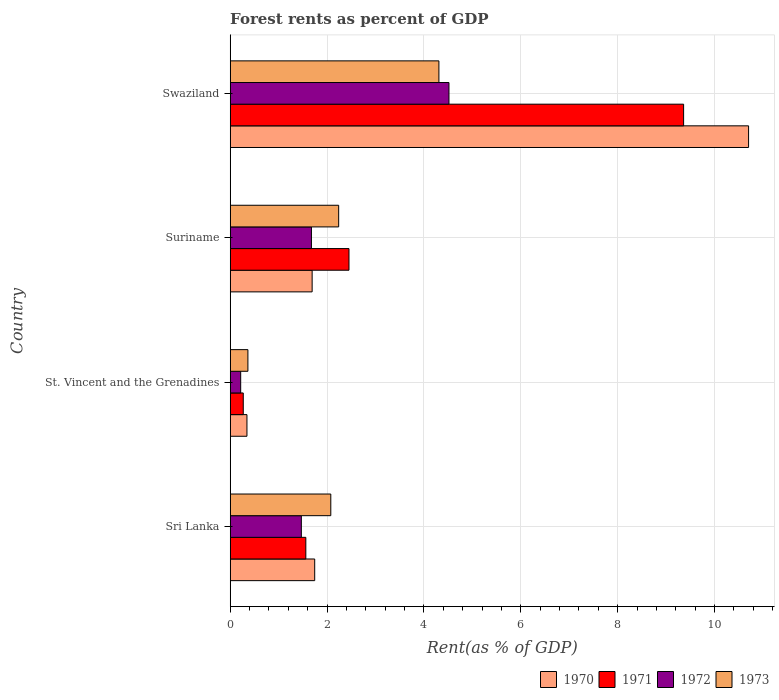How many different coloured bars are there?
Provide a succinct answer. 4. How many groups of bars are there?
Keep it short and to the point. 4. Are the number of bars on each tick of the Y-axis equal?
Provide a succinct answer. Yes. How many bars are there on the 4th tick from the top?
Your response must be concise. 4. How many bars are there on the 3rd tick from the bottom?
Your response must be concise. 4. What is the label of the 1st group of bars from the top?
Keep it short and to the point. Swaziland. In how many cases, is the number of bars for a given country not equal to the number of legend labels?
Your answer should be very brief. 0. What is the forest rent in 1972 in Suriname?
Keep it short and to the point. 1.68. Across all countries, what is the maximum forest rent in 1973?
Make the answer very short. 4.31. Across all countries, what is the minimum forest rent in 1972?
Offer a very short reply. 0.22. In which country was the forest rent in 1972 maximum?
Offer a very short reply. Swaziland. In which country was the forest rent in 1970 minimum?
Give a very brief answer. St. Vincent and the Grenadines. What is the total forest rent in 1971 in the graph?
Provide a succinct answer. 13.65. What is the difference between the forest rent in 1973 in Sri Lanka and that in Suriname?
Offer a terse response. -0.16. What is the difference between the forest rent in 1973 in St. Vincent and the Grenadines and the forest rent in 1972 in Sri Lanka?
Offer a very short reply. -1.1. What is the average forest rent in 1973 per country?
Provide a succinct answer. 2.25. What is the difference between the forest rent in 1972 and forest rent in 1971 in St. Vincent and the Grenadines?
Your answer should be compact. -0.05. What is the ratio of the forest rent in 1973 in St. Vincent and the Grenadines to that in Swaziland?
Provide a short and direct response. 0.08. What is the difference between the highest and the second highest forest rent in 1972?
Ensure brevity in your answer.  2.84. What is the difference between the highest and the lowest forest rent in 1971?
Provide a short and direct response. 9.09. In how many countries, is the forest rent in 1972 greater than the average forest rent in 1972 taken over all countries?
Your answer should be compact. 1. Is the sum of the forest rent in 1970 in Sri Lanka and Suriname greater than the maximum forest rent in 1971 across all countries?
Your answer should be very brief. No. Is it the case that in every country, the sum of the forest rent in 1973 and forest rent in 1972 is greater than the sum of forest rent in 1971 and forest rent in 1970?
Your response must be concise. No. What does the 1st bar from the top in Suriname represents?
Your answer should be compact. 1973. What does the 4th bar from the bottom in Suriname represents?
Your answer should be very brief. 1973. How many countries are there in the graph?
Provide a short and direct response. 4. What is the difference between two consecutive major ticks on the X-axis?
Give a very brief answer. 2. How are the legend labels stacked?
Provide a short and direct response. Horizontal. What is the title of the graph?
Your answer should be very brief. Forest rents as percent of GDP. Does "1989" appear as one of the legend labels in the graph?
Your answer should be very brief. No. What is the label or title of the X-axis?
Your answer should be very brief. Rent(as % of GDP). What is the Rent(as % of GDP) in 1970 in Sri Lanka?
Give a very brief answer. 1.75. What is the Rent(as % of GDP) in 1971 in Sri Lanka?
Your answer should be very brief. 1.56. What is the Rent(as % of GDP) in 1972 in Sri Lanka?
Provide a short and direct response. 1.47. What is the Rent(as % of GDP) of 1973 in Sri Lanka?
Give a very brief answer. 2.08. What is the Rent(as % of GDP) of 1970 in St. Vincent and the Grenadines?
Provide a succinct answer. 0.35. What is the Rent(as % of GDP) of 1971 in St. Vincent and the Grenadines?
Keep it short and to the point. 0.27. What is the Rent(as % of GDP) in 1972 in St. Vincent and the Grenadines?
Give a very brief answer. 0.22. What is the Rent(as % of GDP) in 1973 in St. Vincent and the Grenadines?
Your answer should be compact. 0.37. What is the Rent(as % of GDP) in 1970 in Suriname?
Make the answer very short. 1.69. What is the Rent(as % of GDP) in 1971 in Suriname?
Provide a short and direct response. 2.45. What is the Rent(as % of GDP) in 1972 in Suriname?
Your answer should be very brief. 1.68. What is the Rent(as % of GDP) of 1973 in Suriname?
Provide a short and direct response. 2.24. What is the Rent(as % of GDP) in 1970 in Swaziland?
Offer a very short reply. 10.7. What is the Rent(as % of GDP) of 1971 in Swaziland?
Offer a terse response. 9.36. What is the Rent(as % of GDP) of 1972 in Swaziland?
Ensure brevity in your answer.  4.52. What is the Rent(as % of GDP) of 1973 in Swaziland?
Make the answer very short. 4.31. Across all countries, what is the maximum Rent(as % of GDP) in 1970?
Your answer should be compact. 10.7. Across all countries, what is the maximum Rent(as % of GDP) of 1971?
Your answer should be compact. 9.36. Across all countries, what is the maximum Rent(as % of GDP) in 1972?
Ensure brevity in your answer.  4.52. Across all countries, what is the maximum Rent(as % of GDP) in 1973?
Keep it short and to the point. 4.31. Across all countries, what is the minimum Rent(as % of GDP) of 1970?
Keep it short and to the point. 0.35. Across all countries, what is the minimum Rent(as % of GDP) in 1971?
Your answer should be very brief. 0.27. Across all countries, what is the minimum Rent(as % of GDP) of 1972?
Your response must be concise. 0.22. Across all countries, what is the minimum Rent(as % of GDP) in 1973?
Provide a short and direct response. 0.37. What is the total Rent(as % of GDP) in 1970 in the graph?
Your answer should be very brief. 14.49. What is the total Rent(as % of GDP) in 1971 in the graph?
Ensure brevity in your answer.  13.65. What is the total Rent(as % of GDP) of 1972 in the graph?
Your answer should be compact. 7.88. What is the total Rent(as % of GDP) in 1973 in the graph?
Offer a terse response. 8.99. What is the difference between the Rent(as % of GDP) in 1970 in Sri Lanka and that in St. Vincent and the Grenadines?
Provide a succinct answer. 1.4. What is the difference between the Rent(as % of GDP) of 1971 in Sri Lanka and that in St. Vincent and the Grenadines?
Make the answer very short. 1.29. What is the difference between the Rent(as % of GDP) in 1972 in Sri Lanka and that in St. Vincent and the Grenadines?
Your answer should be compact. 1.25. What is the difference between the Rent(as % of GDP) of 1973 in Sri Lanka and that in St. Vincent and the Grenadines?
Keep it short and to the point. 1.71. What is the difference between the Rent(as % of GDP) in 1970 in Sri Lanka and that in Suriname?
Keep it short and to the point. 0.05. What is the difference between the Rent(as % of GDP) of 1971 in Sri Lanka and that in Suriname?
Make the answer very short. -0.89. What is the difference between the Rent(as % of GDP) in 1972 in Sri Lanka and that in Suriname?
Make the answer very short. -0.21. What is the difference between the Rent(as % of GDP) of 1973 in Sri Lanka and that in Suriname?
Ensure brevity in your answer.  -0.16. What is the difference between the Rent(as % of GDP) of 1970 in Sri Lanka and that in Swaziland?
Offer a very short reply. -8.96. What is the difference between the Rent(as % of GDP) in 1971 in Sri Lanka and that in Swaziland?
Your answer should be very brief. -7.8. What is the difference between the Rent(as % of GDP) in 1972 in Sri Lanka and that in Swaziland?
Provide a succinct answer. -3.05. What is the difference between the Rent(as % of GDP) of 1973 in Sri Lanka and that in Swaziland?
Give a very brief answer. -2.23. What is the difference between the Rent(as % of GDP) of 1970 in St. Vincent and the Grenadines and that in Suriname?
Offer a terse response. -1.35. What is the difference between the Rent(as % of GDP) in 1971 in St. Vincent and the Grenadines and that in Suriname?
Keep it short and to the point. -2.18. What is the difference between the Rent(as % of GDP) of 1972 in St. Vincent and the Grenadines and that in Suriname?
Give a very brief answer. -1.46. What is the difference between the Rent(as % of GDP) of 1973 in St. Vincent and the Grenadines and that in Suriname?
Give a very brief answer. -1.87. What is the difference between the Rent(as % of GDP) of 1970 in St. Vincent and the Grenadines and that in Swaziland?
Keep it short and to the point. -10.36. What is the difference between the Rent(as % of GDP) in 1971 in St. Vincent and the Grenadines and that in Swaziland?
Keep it short and to the point. -9.09. What is the difference between the Rent(as % of GDP) in 1972 in St. Vincent and the Grenadines and that in Swaziland?
Ensure brevity in your answer.  -4.3. What is the difference between the Rent(as % of GDP) of 1973 in St. Vincent and the Grenadines and that in Swaziland?
Provide a succinct answer. -3.94. What is the difference between the Rent(as % of GDP) of 1970 in Suriname and that in Swaziland?
Your answer should be compact. -9.01. What is the difference between the Rent(as % of GDP) of 1971 in Suriname and that in Swaziland?
Offer a terse response. -6.91. What is the difference between the Rent(as % of GDP) of 1972 in Suriname and that in Swaziland?
Provide a short and direct response. -2.84. What is the difference between the Rent(as % of GDP) in 1973 in Suriname and that in Swaziland?
Offer a very short reply. -2.07. What is the difference between the Rent(as % of GDP) in 1970 in Sri Lanka and the Rent(as % of GDP) in 1971 in St. Vincent and the Grenadines?
Make the answer very short. 1.48. What is the difference between the Rent(as % of GDP) in 1970 in Sri Lanka and the Rent(as % of GDP) in 1972 in St. Vincent and the Grenadines?
Keep it short and to the point. 1.53. What is the difference between the Rent(as % of GDP) in 1970 in Sri Lanka and the Rent(as % of GDP) in 1973 in St. Vincent and the Grenadines?
Provide a short and direct response. 1.38. What is the difference between the Rent(as % of GDP) of 1971 in Sri Lanka and the Rent(as % of GDP) of 1972 in St. Vincent and the Grenadines?
Your answer should be compact. 1.34. What is the difference between the Rent(as % of GDP) in 1971 in Sri Lanka and the Rent(as % of GDP) in 1973 in St. Vincent and the Grenadines?
Give a very brief answer. 1.2. What is the difference between the Rent(as % of GDP) of 1972 in Sri Lanka and the Rent(as % of GDP) of 1973 in St. Vincent and the Grenadines?
Give a very brief answer. 1.1. What is the difference between the Rent(as % of GDP) of 1970 in Sri Lanka and the Rent(as % of GDP) of 1971 in Suriname?
Ensure brevity in your answer.  -0.71. What is the difference between the Rent(as % of GDP) of 1970 in Sri Lanka and the Rent(as % of GDP) of 1972 in Suriname?
Provide a succinct answer. 0.07. What is the difference between the Rent(as % of GDP) of 1970 in Sri Lanka and the Rent(as % of GDP) of 1973 in Suriname?
Provide a short and direct response. -0.49. What is the difference between the Rent(as % of GDP) of 1971 in Sri Lanka and the Rent(as % of GDP) of 1972 in Suriname?
Your answer should be very brief. -0.12. What is the difference between the Rent(as % of GDP) in 1971 in Sri Lanka and the Rent(as % of GDP) in 1973 in Suriname?
Offer a terse response. -0.68. What is the difference between the Rent(as % of GDP) of 1972 in Sri Lanka and the Rent(as % of GDP) of 1973 in Suriname?
Your answer should be compact. -0.77. What is the difference between the Rent(as % of GDP) in 1970 in Sri Lanka and the Rent(as % of GDP) in 1971 in Swaziland?
Make the answer very short. -7.62. What is the difference between the Rent(as % of GDP) in 1970 in Sri Lanka and the Rent(as % of GDP) in 1972 in Swaziland?
Your answer should be compact. -2.77. What is the difference between the Rent(as % of GDP) of 1970 in Sri Lanka and the Rent(as % of GDP) of 1973 in Swaziland?
Provide a short and direct response. -2.56. What is the difference between the Rent(as % of GDP) of 1971 in Sri Lanka and the Rent(as % of GDP) of 1972 in Swaziland?
Your answer should be compact. -2.96. What is the difference between the Rent(as % of GDP) of 1971 in Sri Lanka and the Rent(as % of GDP) of 1973 in Swaziland?
Offer a terse response. -2.75. What is the difference between the Rent(as % of GDP) of 1972 in Sri Lanka and the Rent(as % of GDP) of 1973 in Swaziland?
Provide a succinct answer. -2.84. What is the difference between the Rent(as % of GDP) in 1970 in St. Vincent and the Grenadines and the Rent(as % of GDP) in 1971 in Suriname?
Provide a short and direct response. -2.11. What is the difference between the Rent(as % of GDP) of 1970 in St. Vincent and the Grenadines and the Rent(as % of GDP) of 1972 in Suriname?
Your answer should be compact. -1.33. What is the difference between the Rent(as % of GDP) of 1970 in St. Vincent and the Grenadines and the Rent(as % of GDP) of 1973 in Suriname?
Your answer should be compact. -1.89. What is the difference between the Rent(as % of GDP) of 1971 in St. Vincent and the Grenadines and the Rent(as % of GDP) of 1972 in Suriname?
Offer a terse response. -1.41. What is the difference between the Rent(as % of GDP) of 1971 in St. Vincent and the Grenadines and the Rent(as % of GDP) of 1973 in Suriname?
Your answer should be compact. -1.97. What is the difference between the Rent(as % of GDP) in 1972 in St. Vincent and the Grenadines and the Rent(as % of GDP) in 1973 in Suriname?
Offer a very short reply. -2.02. What is the difference between the Rent(as % of GDP) of 1970 in St. Vincent and the Grenadines and the Rent(as % of GDP) of 1971 in Swaziland?
Make the answer very short. -9.02. What is the difference between the Rent(as % of GDP) in 1970 in St. Vincent and the Grenadines and the Rent(as % of GDP) in 1972 in Swaziland?
Your answer should be compact. -4.17. What is the difference between the Rent(as % of GDP) in 1970 in St. Vincent and the Grenadines and the Rent(as % of GDP) in 1973 in Swaziland?
Keep it short and to the point. -3.96. What is the difference between the Rent(as % of GDP) in 1971 in St. Vincent and the Grenadines and the Rent(as % of GDP) in 1972 in Swaziland?
Provide a succinct answer. -4.25. What is the difference between the Rent(as % of GDP) in 1971 in St. Vincent and the Grenadines and the Rent(as % of GDP) in 1973 in Swaziland?
Your answer should be very brief. -4.04. What is the difference between the Rent(as % of GDP) in 1972 in St. Vincent and the Grenadines and the Rent(as % of GDP) in 1973 in Swaziland?
Provide a succinct answer. -4.09. What is the difference between the Rent(as % of GDP) in 1970 in Suriname and the Rent(as % of GDP) in 1971 in Swaziland?
Provide a succinct answer. -7.67. What is the difference between the Rent(as % of GDP) of 1970 in Suriname and the Rent(as % of GDP) of 1972 in Swaziland?
Ensure brevity in your answer.  -2.82. What is the difference between the Rent(as % of GDP) in 1970 in Suriname and the Rent(as % of GDP) in 1973 in Swaziland?
Make the answer very short. -2.62. What is the difference between the Rent(as % of GDP) of 1971 in Suriname and the Rent(as % of GDP) of 1972 in Swaziland?
Provide a short and direct response. -2.06. What is the difference between the Rent(as % of GDP) in 1971 in Suriname and the Rent(as % of GDP) in 1973 in Swaziland?
Offer a terse response. -1.86. What is the difference between the Rent(as % of GDP) of 1972 in Suriname and the Rent(as % of GDP) of 1973 in Swaziland?
Your answer should be compact. -2.63. What is the average Rent(as % of GDP) in 1970 per country?
Keep it short and to the point. 3.62. What is the average Rent(as % of GDP) in 1971 per country?
Give a very brief answer. 3.41. What is the average Rent(as % of GDP) in 1972 per country?
Give a very brief answer. 1.97. What is the average Rent(as % of GDP) in 1973 per country?
Your answer should be very brief. 2.25. What is the difference between the Rent(as % of GDP) of 1970 and Rent(as % of GDP) of 1971 in Sri Lanka?
Provide a short and direct response. 0.18. What is the difference between the Rent(as % of GDP) in 1970 and Rent(as % of GDP) in 1972 in Sri Lanka?
Provide a short and direct response. 0.28. What is the difference between the Rent(as % of GDP) of 1970 and Rent(as % of GDP) of 1973 in Sri Lanka?
Provide a short and direct response. -0.33. What is the difference between the Rent(as % of GDP) in 1971 and Rent(as % of GDP) in 1972 in Sri Lanka?
Keep it short and to the point. 0.09. What is the difference between the Rent(as % of GDP) in 1971 and Rent(as % of GDP) in 1973 in Sri Lanka?
Your answer should be very brief. -0.52. What is the difference between the Rent(as % of GDP) of 1972 and Rent(as % of GDP) of 1973 in Sri Lanka?
Give a very brief answer. -0.61. What is the difference between the Rent(as % of GDP) in 1970 and Rent(as % of GDP) in 1971 in St. Vincent and the Grenadines?
Your response must be concise. 0.08. What is the difference between the Rent(as % of GDP) in 1970 and Rent(as % of GDP) in 1972 in St. Vincent and the Grenadines?
Provide a short and direct response. 0.13. What is the difference between the Rent(as % of GDP) in 1970 and Rent(as % of GDP) in 1973 in St. Vincent and the Grenadines?
Offer a terse response. -0.02. What is the difference between the Rent(as % of GDP) of 1971 and Rent(as % of GDP) of 1972 in St. Vincent and the Grenadines?
Your answer should be compact. 0.05. What is the difference between the Rent(as % of GDP) in 1971 and Rent(as % of GDP) in 1973 in St. Vincent and the Grenadines?
Make the answer very short. -0.1. What is the difference between the Rent(as % of GDP) in 1972 and Rent(as % of GDP) in 1973 in St. Vincent and the Grenadines?
Provide a short and direct response. -0.15. What is the difference between the Rent(as % of GDP) of 1970 and Rent(as % of GDP) of 1971 in Suriname?
Your answer should be compact. -0.76. What is the difference between the Rent(as % of GDP) in 1970 and Rent(as % of GDP) in 1972 in Suriname?
Offer a very short reply. 0.01. What is the difference between the Rent(as % of GDP) of 1970 and Rent(as % of GDP) of 1973 in Suriname?
Offer a very short reply. -0.55. What is the difference between the Rent(as % of GDP) in 1971 and Rent(as % of GDP) in 1972 in Suriname?
Your response must be concise. 0.78. What is the difference between the Rent(as % of GDP) in 1971 and Rent(as % of GDP) in 1973 in Suriname?
Keep it short and to the point. 0.21. What is the difference between the Rent(as % of GDP) in 1972 and Rent(as % of GDP) in 1973 in Suriname?
Provide a short and direct response. -0.56. What is the difference between the Rent(as % of GDP) in 1970 and Rent(as % of GDP) in 1971 in Swaziland?
Provide a short and direct response. 1.34. What is the difference between the Rent(as % of GDP) in 1970 and Rent(as % of GDP) in 1972 in Swaziland?
Provide a short and direct response. 6.19. What is the difference between the Rent(as % of GDP) in 1970 and Rent(as % of GDP) in 1973 in Swaziland?
Make the answer very short. 6.39. What is the difference between the Rent(as % of GDP) in 1971 and Rent(as % of GDP) in 1972 in Swaziland?
Keep it short and to the point. 4.84. What is the difference between the Rent(as % of GDP) in 1971 and Rent(as % of GDP) in 1973 in Swaziland?
Your answer should be compact. 5.05. What is the difference between the Rent(as % of GDP) of 1972 and Rent(as % of GDP) of 1973 in Swaziland?
Provide a succinct answer. 0.21. What is the ratio of the Rent(as % of GDP) of 1970 in Sri Lanka to that in St. Vincent and the Grenadines?
Give a very brief answer. 5.04. What is the ratio of the Rent(as % of GDP) of 1971 in Sri Lanka to that in St. Vincent and the Grenadines?
Provide a short and direct response. 5.78. What is the ratio of the Rent(as % of GDP) of 1972 in Sri Lanka to that in St. Vincent and the Grenadines?
Make the answer very short. 6.77. What is the ratio of the Rent(as % of GDP) in 1973 in Sri Lanka to that in St. Vincent and the Grenadines?
Your response must be concise. 5.68. What is the ratio of the Rent(as % of GDP) in 1970 in Sri Lanka to that in Suriname?
Give a very brief answer. 1.03. What is the ratio of the Rent(as % of GDP) of 1971 in Sri Lanka to that in Suriname?
Your answer should be compact. 0.64. What is the ratio of the Rent(as % of GDP) of 1972 in Sri Lanka to that in Suriname?
Give a very brief answer. 0.88. What is the ratio of the Rent(as % of GDP) of 1973 in Sri Lanka to that in Suriname?
Keep it short and to the point. 0.93. What is the ratio of the Rent(as % of GDP) of 1970 in Sri Lanka to that in Swaziland?
Your response must be concise. 0.16. What is the ratio of the Rent(as % of GDP) of 1971 in Sri Lanka to that in Swaziland?
Ensure brevity in your answer.  0.17. What is the ratio of the Rent(as % of GDP) of 1972 in Sri Lanka to that in Swaziland?
Offer a very short reply. 0.33. What is the ratio of the Rent(as % of GDP) in 1973 in Sri Lanka to that in Swaziland?
Provide a short and direct response. 0.48. What is the ratio of the Rent(as % of GDP) of 1970 in St. Vincent and the Grenadines to that in Suriname?
Your response must be concise. 0.2. What is the ratio of the Rent(as % of GDP) of 1971 in St. Vincent and the Grenadines to that in Suriname?
Your response must be concise. 0.11. What is the ratio of the Rent(as % of GDP) in 1972 in St. Vincent and the Grenadines to that in Suriname?
Give a very brief answer. 0.13. What is the ratio of the Rent(as % of GDP) in 1973 in St. Vincent and the Grenadines to that in Suriname?
Make the answer very short. 0.16. What is the ratio of the Rent(as % of GDP) of 1970 in St. Vincent and the Grenadines to that in Swaziland?
Your answer should be very brief. 0.03. What is the ratio of the Rent(as % of GDP) of 1971 in St. Vincent and the Grenadines to that in Swaziland?
Provide a short and direct response. 0.03. What is the ratio of the Rent(as % of GDP) of 1972 in St. Vincent and the Grenadines to that in Swaziland?
Your answer should be compact. 0.05. What is the ratio of the Rent(as % of GDP) in 1973 in St. Vincent and the Grenadines to that in Swaziland?
Your answer should be very brief. 0.08. What is the ratio of the Rent(as % of GDP) in 1970 in Suriname to that in Swaziland?
Make the answer very short. 0.16. What is the ratio of the Rent(as % of GDP) in 1971 in Suriname to that in Swaziland?
Offer a very short reply. 0.26. What is the ratio of the Rent(as % of GDP) of 1972 in Suriname to that in Swaziland?
Give a very brief answer. 0.37. What is the ratio of the Rent(as % of GDP) in 1973 in Suriname to that in Swaziland?
Keep it short and to the point. 0.52. What is the difference between the highest and the second highest Rent(as % of GDP) of 1970?
Your response must be concise. 8.96. What is the difference between the highest and the second highest Rent(as % of GDP) of 1971?
Provide a succinct answer. 6.91. What is the difference between the highest and the second highest Rent(as % of GDP) in 1972?
Keep it short and to the point. 2.84. What is the difference between the highest and the second highest Rent(as % of GDP) in 1973?
Provide a succinct answer. 2.07. What is the difference between the highest and the lowest Rent(as % of GDP) of 1970?
Offer a terse response. 10.36. What is the difference between the highest and the lowest Rent(as % of GDP) in 1971?
Your response must be concise. 9.09. What is the difference between the highest and the lowest Rent(as % of GDP) of 1972?
Your answer should be very brief. 4.3. What is the difference between the highest and the lowest Rent(as % of GDP) in 1973?
Ensure brevity in your answer.  3.94. 